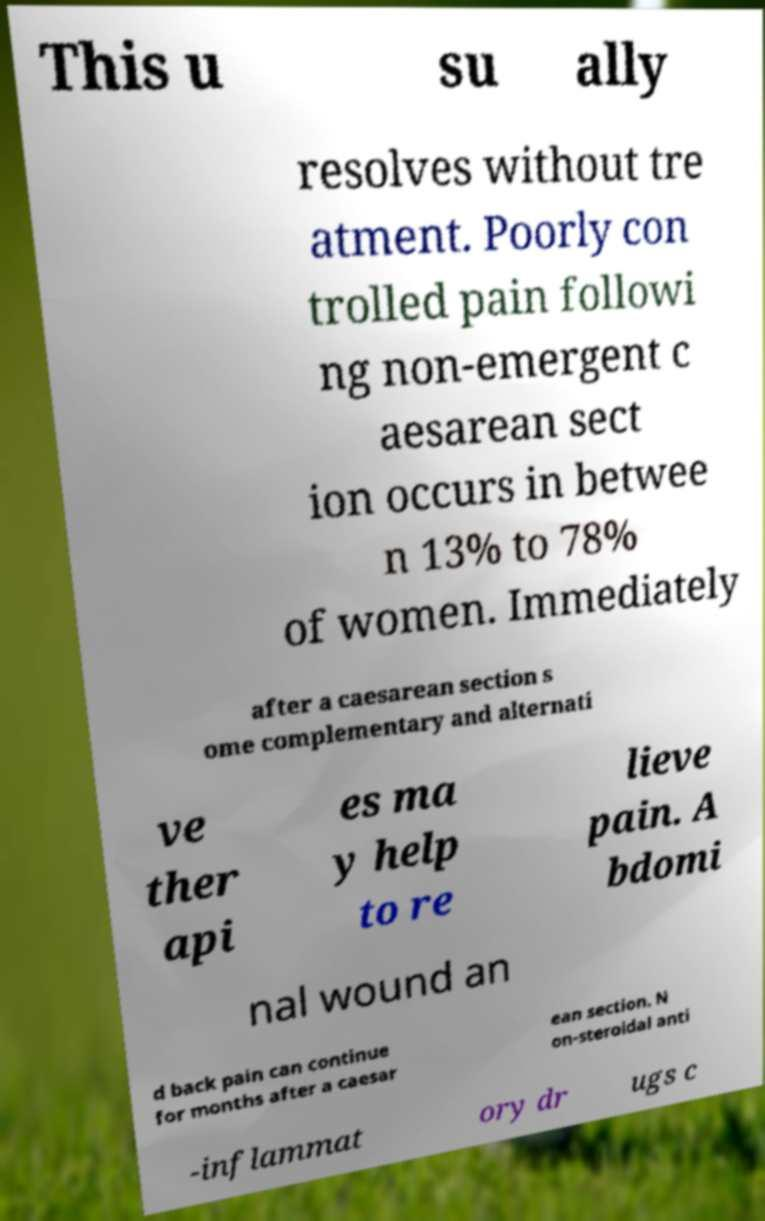Can you accurately transcribe the text from the provided image for me? This u su ally resolves without tre atment. Poorly con trolled pain followi ng non-emergent c aesarean sect ion occurs in betwee n 13% to 78% of women. Immediately after a caesarean section s ome complementary and alternati ve ther api es ma y help to re lieve pain. A bdomi nal wound an d back pain can continue for months after a caesar ean section. N on-steroidal anti -inflammat ory dr ugs c 